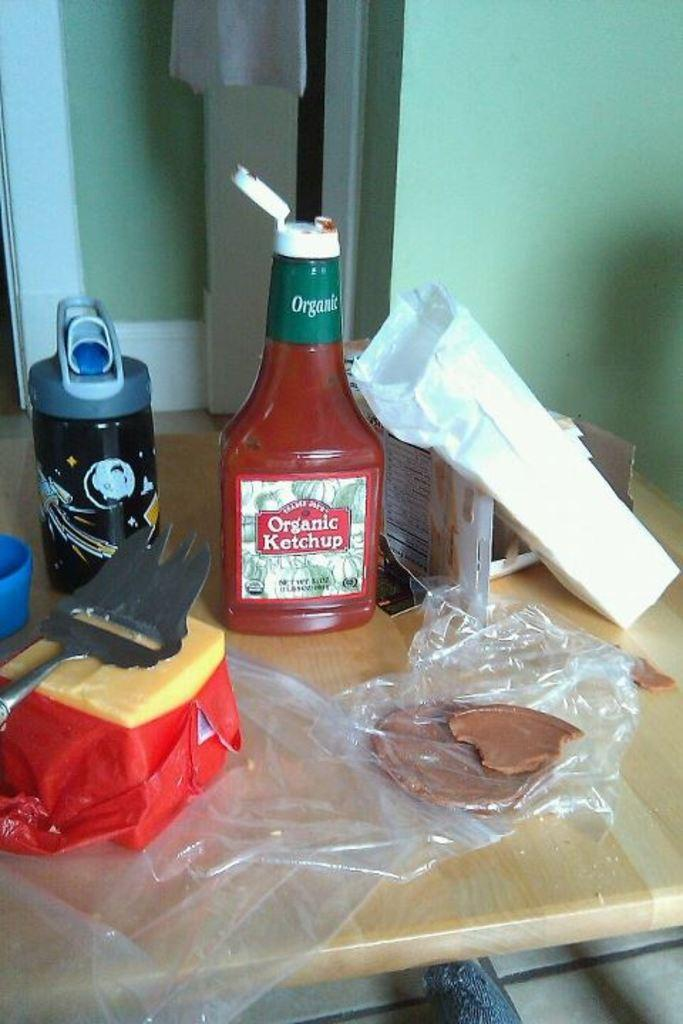Provide a one-sentence caption for the provided image. A bottle or organic ketchup sits open on a table along with some other food. 